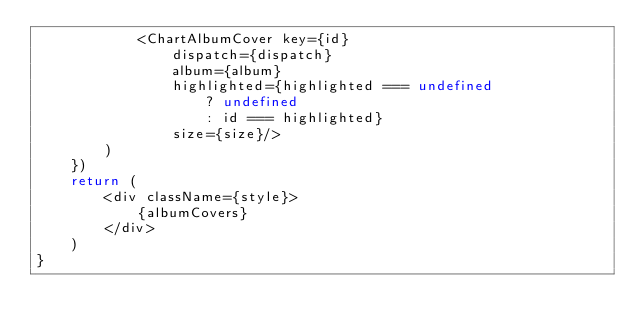<code> <loc_0><loc_0><loc_500><loc_500><_TypeScript_>            <ChartAlbumCover key={id}
                dispatch={dispatch}
                album={album}
                highlighted={highlighted === undefined
                    ? undefined
                    : id === highlighted}
                size={size}/>
        )
    })
    return (
        <div className={style}>
            {albumCovers}
        </div>
    )
}
</code> 